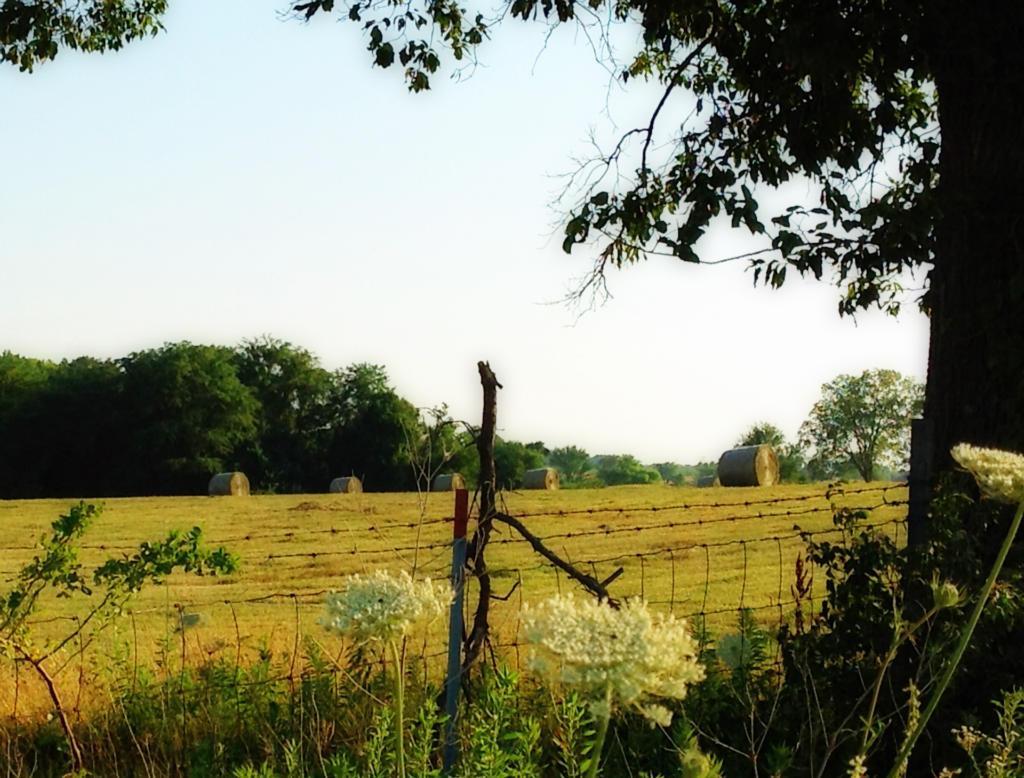Could you give a brief overview of what you see in this image? Here in this picture, in the front we can see fencing present and we can also see some plants present and we can see the ground is fully covered with grass and we can also see other plants and trees present and we can see the sky is cloudy. 